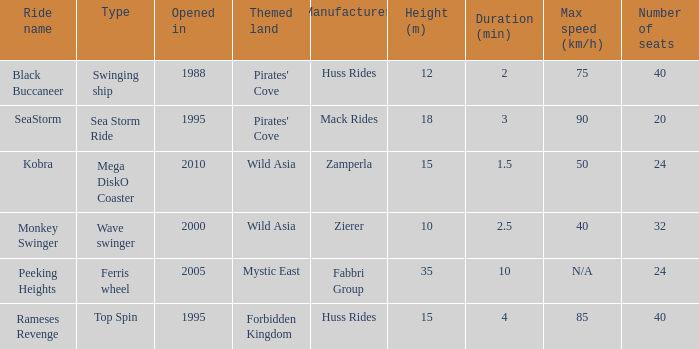What type ride is Wild Asia that opened in 2000? Wave swinger. 